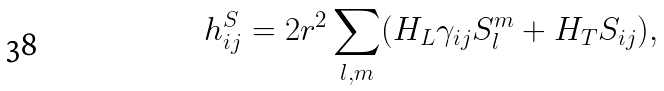<formula> <loc_0><loc_0><loc_500><loc_500>h _ { i j } ^ { S } = 2 r ^ { 2 } \sum _ { l , m } ( H _ { L } \gamma _ { i j } S _ { l } ^ { m } + H _ { T } S _ { i j } ) ,</formula> 